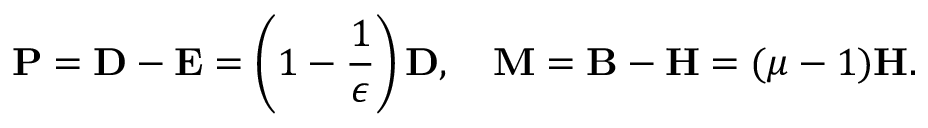Convert formula to latex. <formula><loc_0><loc_0><loc_500><loc_500>{ P } = { D - E } = \left ( 1 - { \frac { 1 } { \epsilon } } \right ) { D } , \quad M = { B - H } = ( \mu - 1 ) { H } .</formula> 